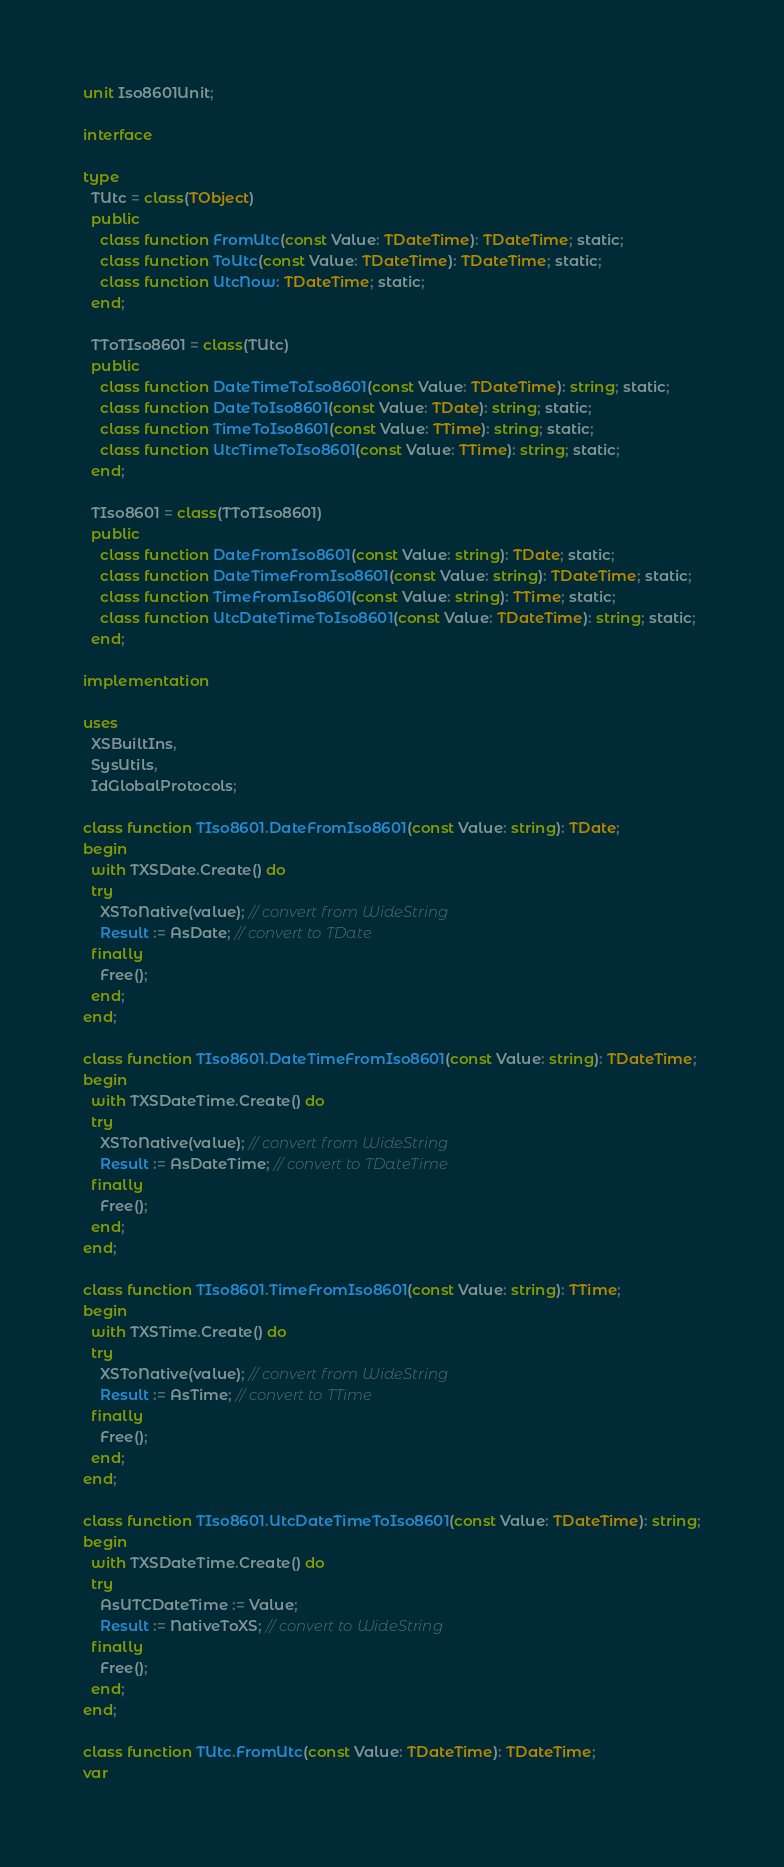<code> <loc_0><loc_0><loc_500><loc_500><_Pascal_>unit Iso8601Unit;

interface

type
  TUtc = class(TObject)
  public
    class function FromUtc(const Value: TDateTime): TDateTime; static;
    class function ToUtc(const Value: TDateTime): TDateTime; static;
    class function UtcNow: TDateTime; static;
  end;

  TToTIso8601 = class(TUtc)
  public
    class function DateTimeToIso8601(const Value: TDateTime): string; static;
    class function DateToIso8601(const Value: TDate): string; static;
    class function TimeToIso8601(const Value: TTime): string; static;
    class function UtcTimeToIso8601(const Value: TTime): string; static;
  end;

  TIso8601 = class(TToTIso8601)
  public
    class function DateFromIso8601(const Value: string): TDate; static;
    class function DateTimeFromIso8601(const Value: string): TDateTime; static;
    class function TimeFromIso8601(const Value: string): TTime; static;
    class function UtcDateTimeToIso8601(const Value: TDateTime): string; static;
  end;

implementation

uses
  XSBuiltIns,
  SysUtils,
  IdGlobalProtocols;

class function TIso8601.DateFromIso8601(const Value: string): TDate;
begin
  with TXSDate.Create() do
  try
    XSToNative(value); // convert from WideString
    Result := AsDate; // convert to TDate
  finally
    Free();
  end;
end;

class function TIso8601.DateTimeFromIso8601(const Value: string): TDateTime;
begin
  with TXSDateTime.Create() do
  try
    XSToNative(value); // convert from WideString
    Result := AsDateTime; // convert to TDateTime
  finally
    Free();
  end;
end;

class function TIso8601.TimeFromIso8601(const Value: string): TTime;
begin
  with TXSTime.Create() do
  try
    XSToNative(value); // convert from WideString
    Result := AsTime; // convert to TTime
  finally
    Free();
  end;
end;

class function TIso8601.UtcDateTimeToIso8601(const Value: TDateTime): string;
begin
  with TXSDateTime.Create() do
  try
    AsUTCDateTime := Value;
    Result := NativeToXS; // convert to WideString
  finally
    Free();
  end;
end;

class function TUtc.FromUtc(const Value: TDateTime): TDateTime;
var</code> 